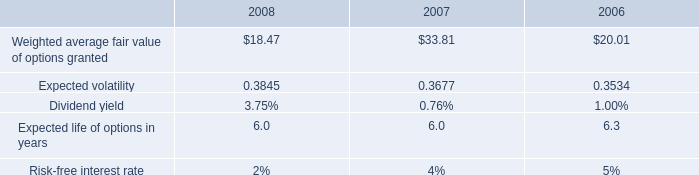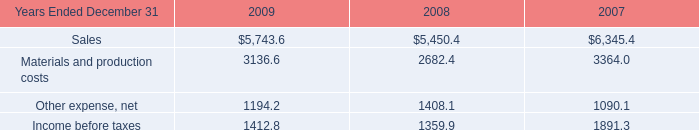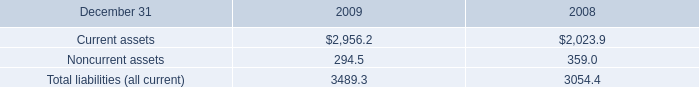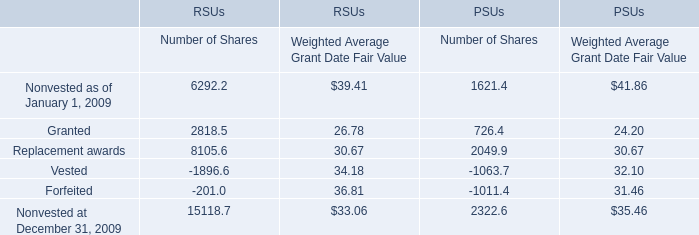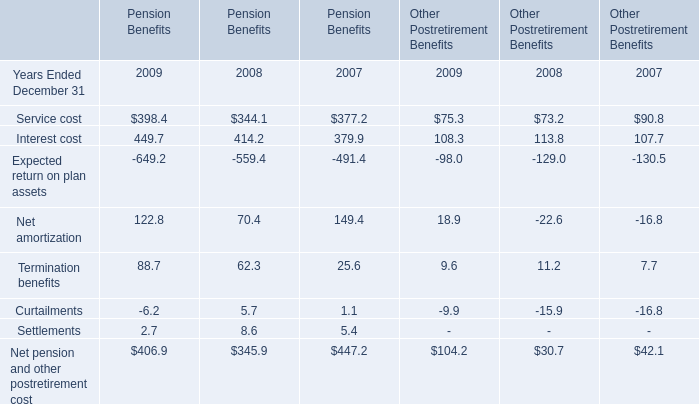What is the sum of Income before taxes of 2009, and Current assets of 2009 ? 
Computations: (1412.8 + 2956.2)
Answer: 4369.0. 